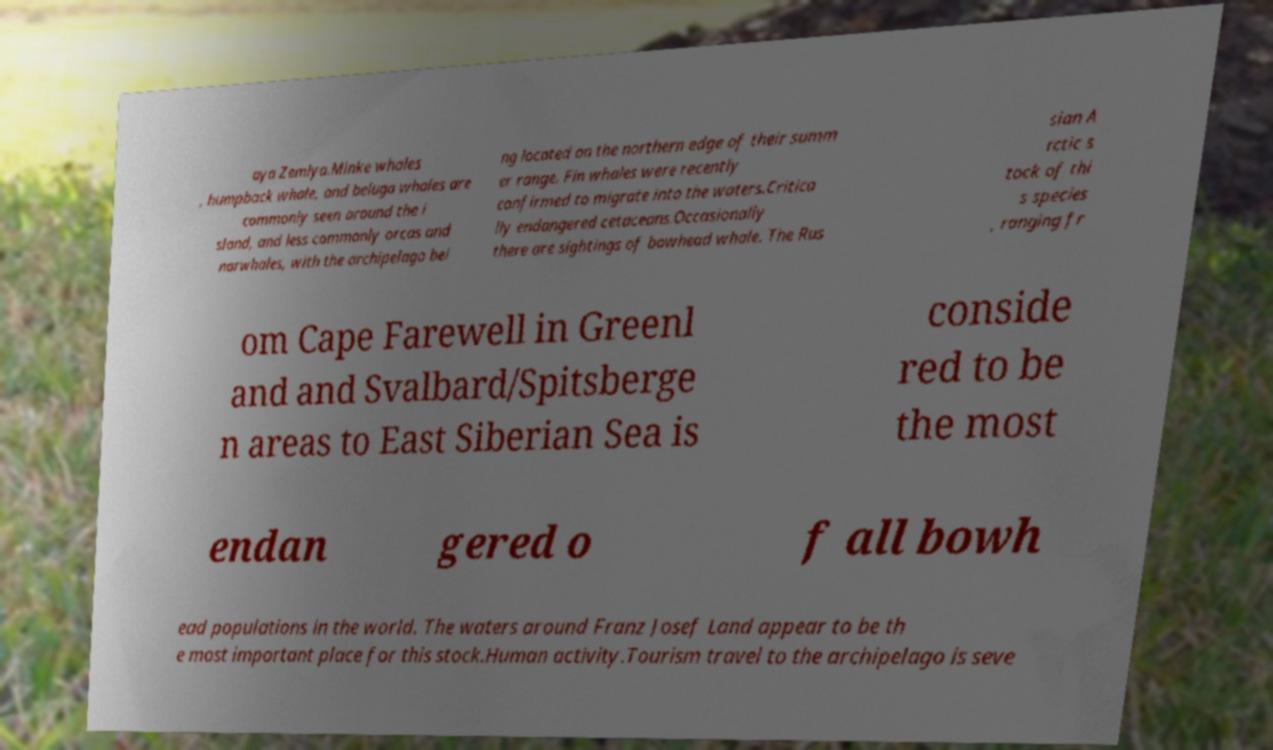Can you read and provide the text displayed in the image?This photo seems to have some interesting text. Can you extract and type it out for me? aya Zemlya.Minke whales , humpback whale, and beluga whales are commonly seen around the i sland, and less commonly orcas and narwhales, with the archipelago bei ng located on the northern edge of their summ er range. Fin whales were recently confirmed to migrate into the waters.Critica lly endangered cetaceans.Occasionally there are sightings of bowhead whale. The Rus sian A rctic s tock of thi s species , ranging fr om Cape Farewell in Greenl and and Svalbard/Spitsberge n areas to East Siberian Sea is conside red to be the most endan gered o f all bowh ead populations in the world. The waters around Franz Josef Land appear to be th e most important place for this stock.Human activity.Tourism travel to the archipelago is seve 